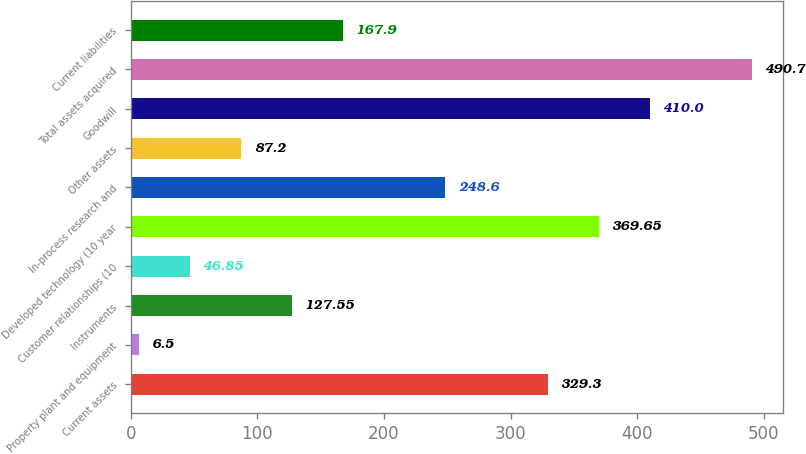<chart> <loc_0><loc_0><loc_500><loc_500><bar_chart><fcel>Current assets<fcel>Property plant and equipment<fcel>Instruments<fcel>Customer relationships (10<fcel>Developed technology (10 year<fcel>In-process research and<fcel>Other assets<fcel>Goodwill<fcel>Total assets acquired<fcel>Current liabilities<nl><fcel>329.3<fcel>6.5<fcel>127.55<fcel>46.85<fcel>369.65<fcel>248.6<fcel>87.2<fcel>410<fcel>490.7<fcel>167.9<nl></chart> 